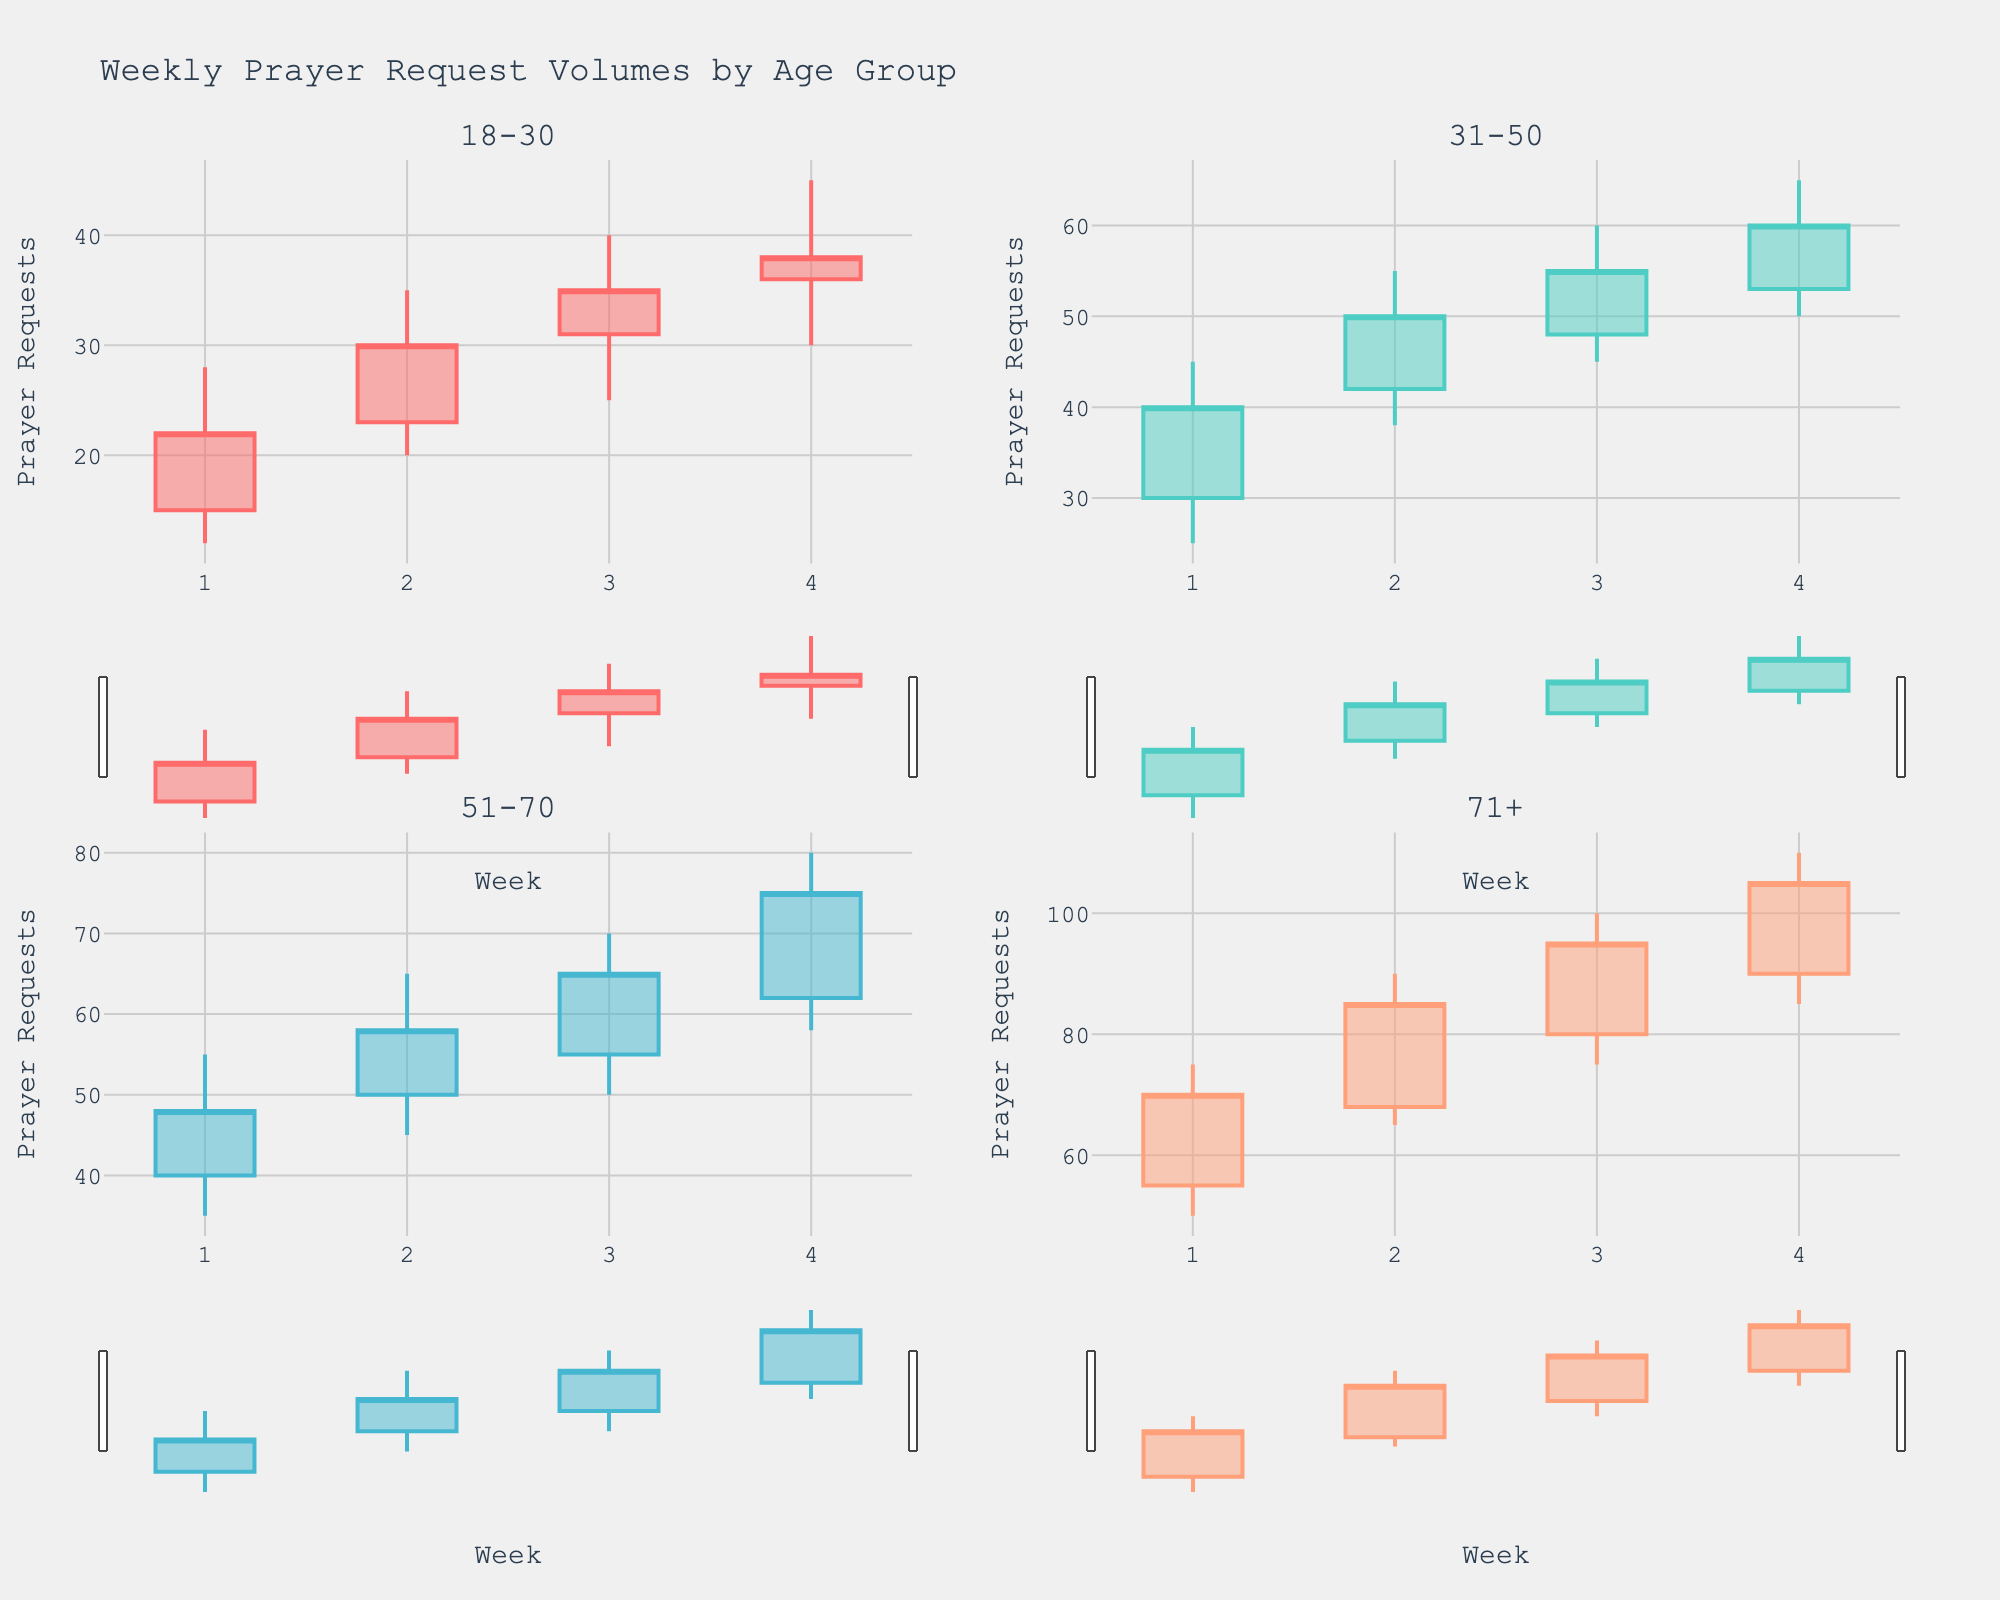What's the title of the chart? The chart's title is displayed at the top of the figure. It reads "Weekly Prayer Request Volumes by Age Group".
Answer: Weekly Prayer Request Volumes by Age Group How many age groups are depicted in the chart? By looking at the subplot titles and the number of candlestick plots, we can see that there are four different age groups depicted in the chart.
Answer: Four Which age group had the highest peak in prayer requests during any week? To find the highest peak, examine the highest points on each candlestick plot. The age group '71+' has the highest peak prayer requests at 110 in Week 4.
Answer: 71+ In which week does the '18-30' age group have the lowest opening prayer requests? Examine the candlestick plot for the '18-30' age group and identify the opening values. The lowest opening is in Week 1 with a value of 15.
Answer: Week 1 Compare the closing prayer requests between the '31-50' and '51-70' age groups in Week 4. Which one is higher? By checking the closing values of Week 4 for both age groups, '31-50' has a closing value of 60 and '51-70' has a closing value of 75. Therefore, '51-70' has a higher closing value.
Answer: 51-70 What is the average closing value for the '51-70' age group over all weeks? Sum the weekly closing values for '51-70' (48, 58, 65, 75) and divide by the number of weeks (4). (48+58+65+75)/4 = 246/4 = 61.5.
Answer: 61.5 In the '71+' age group, which week shows the greatest difference between the high and low values? Calculate the high-low difference for each week in '71+' (Week 1: 75-50=25, Week 2: 90-65=25, Week 3: 100-75=25, Week 4: 110-85=25). All weeks have the same difference of 25.
Answer: All weeks Did any age group experience a decrease in prayer requests in any week? By examining candlestick patterns for all age groups: No week shows a decreasing pattern (where the closing value is less than the opening value) across any age group.
Answer: None Which age group shows the most significant increase (highest positive difference between opening and closing values) in prayer requests in any week? Identify the weeks where the closing value is substantially higher than the opening value: '71+' in Week 1 has an increase from 55 (open) to 70 (close), giving an increase of 15. Other increases (18-30 from 23 to 35, 31-50 from 30 to 40, etc.) are less than 15.
Answer: 71+ 